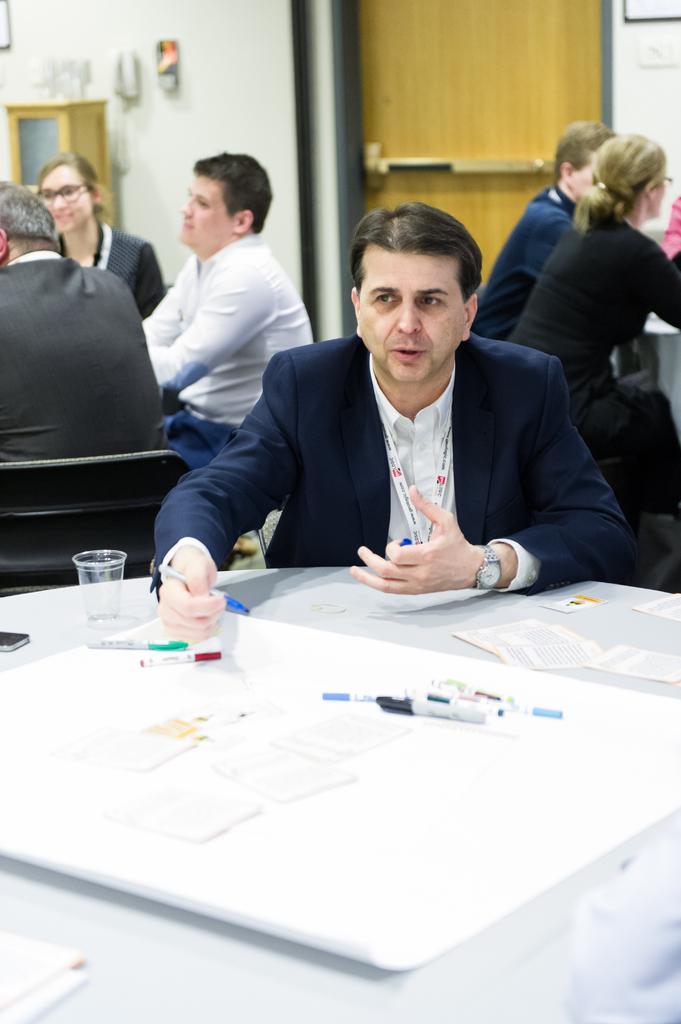Can you describe this image briefly? In this image I can see the group of people with different color dresses. I can see the table in-front of one person. On the table I can see the papers, pens and glass. The table is in white color.. In the background I can see door and the wall. 